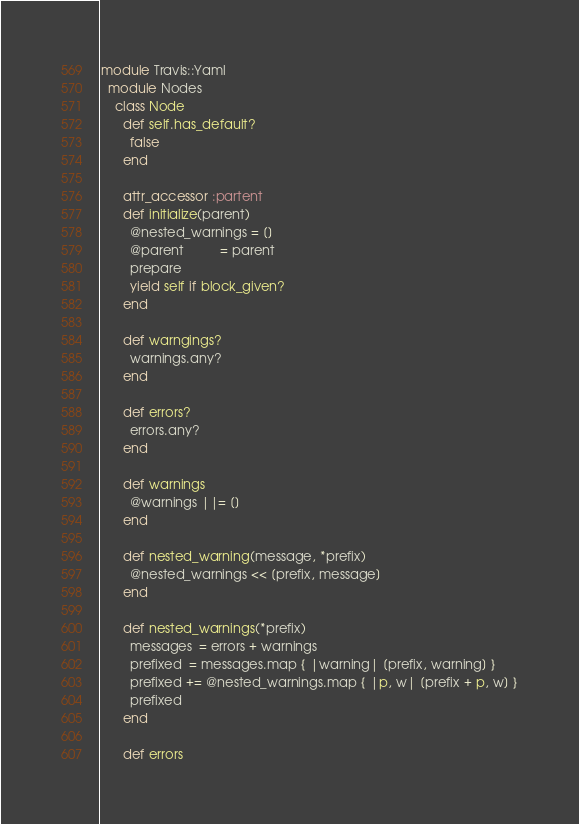<code> <loc_0><loc_0><loc_500><loc_500><_Ruby_>module Travis::Yaml
  module Nodes
    class Node
      def self.has_default?
        false
      end

      attr_accessor :partent
      def initialize(parent)
        @nested_warnings = []
        @parent          = parent
        prepare
        yield self if block_given?
      end

      def warngings?
        warnings.any?
      end

      def errors?
        errors.any?
      end

      def warnings
        @warnings ||= []
      end

      def nested_warning(message, *prefix)
        @nested_warnings << [prefix, message]
      end

      def nested_warnings(*prefix)
        messages  = errors + warnings
        prefixed  = messages.map { |warning| [prefix, warning] }
        prefixed += @nested_warnings.map { |p, w| [prefix + p, w] }
        prefixed
      end

      def errors</code> 